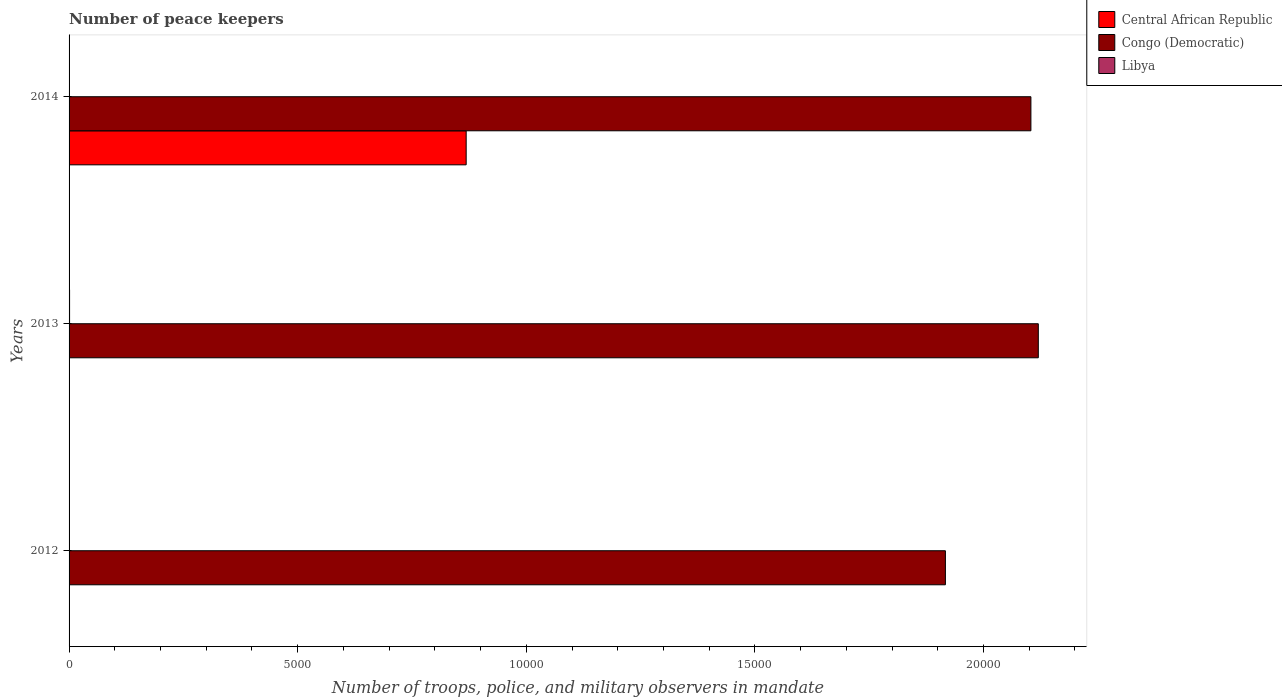How many different coloured bars are there?
Make the answer very short. 3. Are the number of bars per tick equal to the number of legend labels?
Your response must be concise. Yes. How many bars are there on the 3rd tick from the top?
Make the answer very short. 3. In how many cases, is the number of bars for a given year not equal to the number of legend labels?
Offer a terse response. 0. What is the number of peace keepers in in Congo (Democratic) in 2013?
Your answer should be compact. 2.12e+04. Across all years, what is the maximum number of peace keepers in in Congo (Democratic)?
Ensure brevity in your answer.  2.12e+04. In which year was the number of peace keepers in in Central African Republic minimum?
Ensure brevity in your answer.  2012. What is the total number of peace keepers in in Central African Republic in the graph?
Ensure brevity in your answer.  8693. What is the difference between the number of peace keepers in in Libya in 2012 and that in 2013?
Provide a short and direct response. -9. What is the difference between the number of peace keepers in in Central African Republic in 2013 and the number of peace keepers in in Libya in 2012?
Your answer should be compact. 2. In the year 2014, what is the difference between the number of peace keepers in in Congo (Democratic) and number of peace keepers in in Libya?
Ensure brevity in your answer.  2.10e+04. In how many years, is the number of peace keepers in in Congo (Democratic) greater than 21000 ?
Make the answer very short. 2. What is the ratio of the number of peace keepers in in Central African Republic in 2013 to that in 2014?
Give a very brief answer. 0. What is the difference between the highest and the second highest number of peace keepers in in Congo (Democratic)?
Your answer should be very brief. 162. What is the difference between the highest and the lowest number of peace keepers in in Central African Republic?
Your answer should be very brief. 8681. What does the 1st bar from the top in 2012 represents?
Offer a very short reply. Libya. What does the 2nd bar from the bottom in 2012 represents?
Ensure brevity in your answer.  Congo (Democratic). Is it the case that in every year, the sum of the number of peace keepers in in Congo (Democratic) and number of peace keepers in in Central African Republic is greater than the number of peace keepers in in Libya?
Offer a very short reply. Yes. Are all the bars in the graph horizontal?
Offer a terse response. Yes. How many years are there in the graph?
Provide a succinct answer. 3. Are the values on the major ticks of X-axis written in scientific E-notation?
Your response must be concise. No. Does the graph contain any zero values?
Ensure brevity in your answer.  No. Does the graph contain grids?
Your answer should be compact. No. How many legend labels are there?
Give a very brief answer. 3. How are the legend labels stacked?
Your answer should be compact. Vertical. What is the title of the graph?
Provide a short and direct response. Number of peace keepers. What is the label or title of the X-axis?
Provide a succinct answer. Number of troops, police, and military observers in mandate. What is the label or title of the Y-axis?
Offer a very short reply. Years. What is the Number of troops, police, and military observers in mandate of Central African Republic in 2012?
Your response must be concise. 4. What is the Number of troops, police, and military observers in mandate in Congo (Democratic) in 2012?
Offer a terse response. 1.92e+04. What is the Number of troops, police, and military observers in mandate in Libya in 2012?
Provide a short and direct response. 2. What is the Number of troops, police, and military observers in mandate in Central African Republic in 2013?
Provide a succinct answer. 4. What is the Number of troops, police, and military observers in mandate of Congo (Democratic) in 2013?
Provide a succinct answer. 2.12e+04. What is the Number of troops, police, and military observers in mandate in Libya in 2013?
Give a very brief answer. 11. What is the Number of troops, police, and military observers in mandate of Central African Republic in 2014?
Offer a terse response. 8685. What is the Number of troops, police, and military observers in mandate of Congo (Democratic) in 2014?
Keep it short and to the point. 2.10e+04. What is the Number of troops, police, and military observers in mandate of Libya in 2014?
Ensure brevity in your answer.  2. Across all years, what is the maximum Number of troops, police, and military observers in mandate of Central African Republic?
Offer a terse response. 8685. Across all years, what is the maximum Number of troops, police, and military observers in mandate in Congo (Democratic)?
Provide a short and direct response. 2.12e+04. Across all years, what is the maximum Number of troops, police, and military observers in mandate of Libya?
Your answer should be compact. 11. Across all years, what is the minimum Number of troops, police, and military observers in mandate in Central African Republic?
Ensure brevity in your answer.  4. Across all years, what is the minimum Number of troops, police, and military observers in mandate in Congo (Democratic)?
Give a very brief answer. 1.92e+04. What is the total Number of troops, police, and military observers in mandate of Central African Republic in the graph?
Keep it short and to the point. 8693. What is the total Number of troops, police, and military observers in mandate in Congo (Democratic) in the graph?
Make the answer very short. 6.14e+04. What is the total Number of troops, police, and military observers in mandate of Libya in the graph?
Ensure brevity in your answer.  15. What is the difference between the Number of troops, police, and military observers in mandate of Congo (Democratic) in 2012 and that in 2013?
Give a very brief answer. -2032. What is the difference between the Number of troops, police, and military observers in mandate in Libya in 2012 and that in 2013?
Ensure brevity in your answer.  -9. What is the difference between the Number of troops, police, and military observers in mandate of Central African Republic in 2012 and that in 2014?
Your answer should be very brief. -8681. What is the difference between the Number of troops, police, and military observers in mandate of Congo (Democratic) in 2012 and that in 2014?
Offer a terse response. -1870. What is the difference between the Number of troops, police, and military observers in mandate in Central African Republic in 2013 and that in 2014?
Keep it short and to the point. -8681. What is the difference between the Number of troops, police, and military observers in mandate in Congo (Democratic) in 2013 and that in 2014?
Ensure brevity in your answer.  162. What is the difference between the Number of troops, police, and military observers in mandate of Central African Republic in 2012 and the Number of troops, police, and military observers in mandate of Congo (Democratic) in 2013?
Your answer should be compact. -2.12e+04. What is the difference between the Number of troops, police, and military observers in mandate of Central African Republic in 2012 and the Number of troops, police, and military observers in mandate of Libya in 2013?
Offer a terse response. -7. What is the difference between the Number of troops, police, and military observers in mandate of Congo (Democratic) in 2012 and the Number of troops, police, and military observers in mandate of Libya in 2013?
Provide a short and direct response. 1.92e+04. What is the difference between the Number of troops, police, and military observers in mandate in Central African Republic in 2012 and the Number of troops, police, and military observers in mandate in Congo (Democratic) in 2014?
Ensure brevity in your answer.  -2.10e+04. What is the difference between the Number of troops, police, and military observers in mandate of Congo (Democratic) in 2012 and the Number of troops, police, and military observers in mandate of Libya in 2014?
Your answer should be very brief. 1.92e+04. What is the difference between the Number of troops, police, and military observers in mandate in Central African Republic in 2013 and the Number of troops, police, and military observers in mandate in Congo (Democratic) in 2014?
Offer a very short reply. -2.10e+04. What is the difference between the Number of troops, police, and military observers in mandate in Central African Republic in 2013 and the Number of troops, police, and military observers in mandate in Libya in 2014?
Provide a succinct answer. 2. What is the difference between the Number of troops, police, and military observers in mandate in Congo (Democratic) in 2013 and the Number of troops, police, and military observers in mandate in Libya in 2014?
Provide a succinct answer. 2.12e+04. What is the average Number of troops, police, and military observers in mandate in Central African Republic per year?
Provide a short and direct response. 2897.67. What is the average Number of troops, police, and military observers in mandate of Congo (Democratic) per year?
Provide a succinct answer. 2.05e+04. What is the average Number of troops, police, and military observers in mandate in Libya per year?
Your answer should be very brief. 5. In the year 2012, what is the difference between the Number of troops, police, and military observers in mandate of Central African Republic and Number of troops, police, and military observers in mandate of Congo (Democratic)?
Give a very brief answer. -1.92e+04. In the year 2012, what is the difference between the Number of troops, police, and military observers in mandate in Congo (Democratic) and Number of troops, police, and military observers in mandate in Libya?
Provide a short and direct response. 1.92e+04. In the year 2013, what is the difference between the Number of troops, police, and military observers in mandate of Central African Republic and Number of troops, police, and military observers in mandate of Congo (Democratic)?
Offer a very short reply. -2.12e+04. In the year 2013, what is the difference between the Number of troops, police, and military observers in mandate of Congo (Democratic) and Number of troops, police, and military observers in mandate of Libya?
Offer a terse response. 2.12e+04. In the year 2014, what is the difference between the Number of troops, police, and military observers in mandate of Central African Republic and Number of troops, police, and military observers in mandate of Congo (Democratic)?
Provide a succinct answer. -1.24e+04. In the year 2014, what is the difference between the Number of troops, police, and military observers in mandate of Central African Republic and Number of troops, police, and military observers in mandate of Libya?
Offer a very short reply. 8683. In the year 2014, what is the difference between the Number of troops, police, and military observers in mandate of Congo (Democratic) and Number of troops, police, and military observers in mandate of Libya?
Provide a succinct answer. 2.10e+04. What is the ratio of the Number of troops, police, and military observers in mandate of Congo (Democratic) in 2012 to that in 2013?
Offer a very short reply. 0.9. What is the ratio of the Number of troops, police, and military observers in mandate of Libya in 2012 to that in 2013?
Your answer should be compact. 0.18. What is the ratio of the Number of troops, police, and military observers in mandate in Central African Republic in 2012 to that in 2014?
Keep it short and to the point. 0. What is the ratio of the Number of troops, police, and military observers in mandate of Congo (Democratic) in 2012 to that in 2014?
Ensure brevity in your answer.  0.91. What is the ratio of the Number of troops, police, and military observers in mandate in Libya in 2012 to that in 2014?
Make the answer very short. 1. What is the ratio of the Number of troops, police, and military observers in mandate of Central African Republic in 2013 to that in 2014?
Ensure brevity in your answer.  0. What is the ratio of the Number of troops, police, and military observers in mandate in Congo (Democratic) in 2013 to that in 2014?
Provide a succinct answer. 1.01. What is the difference between the highest and the second highest Number of troops, police, and military observers in mandate of Central African Republic?
Keep it short and to the point. 8681. What is the difference between the highest and the second highest Number of troops, police, and military observers in mandate of Congo (Democratic)?
Your answer should be compact. 162. What is the difference between the highest and the lowest Number of troops, police, and military observers in mandate in Central African Republic?
Your response must be concise. 8681. What is the difference between the highest and the lowest Number of troops, police, and military observers in mandate in Congo (Democratic)?
Provide a succinct answer. 2032. 